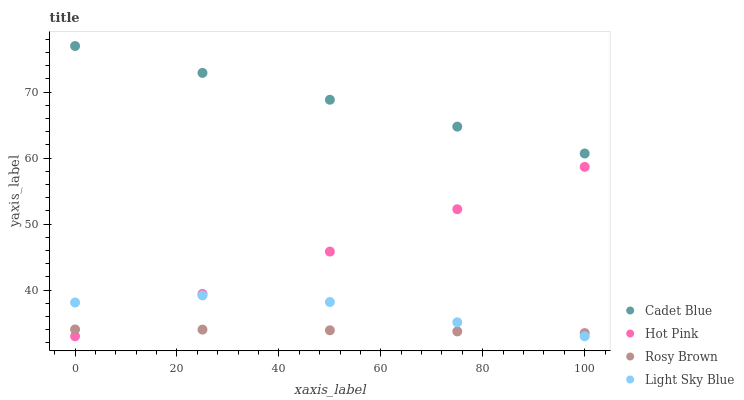Does Rosy Brown have the minimum area under the curve?
Answer yes or no. Yes. Does Cadet Blue have the maximum area under the curve?
Answer yes or no. Yes. Does Light Sky Blue have the minimum area under the curve?
Answer yes or no. No. Does Light Sky Blue have the maximum area under the curve?
Answer yes or no. No. Is Hot Pink the smoothest?
Answer yes or no. Yes. Is Light Sky Blue the roughest?
Answer yes or no. Yes. Is Cadet Blue the smoothest?
Answer yes or no. No. Is Cadet Blue the roughest?
Answer yes or no. No. Does Light Sky Blue have the lowest value?
Answer yes or no. Yes. Does Cadet Blue have the lowest value?
Answer yes or no. No. Does Cadet Blue have the highest value?
Answer yes or no. Yes. Does Light Sky Blue have the highest value?
Answer yes or no. No. Is Light Sky Blue less than Cadet Blue?
Answer yes or no. Yes. Is Cadet Blue greater than Rosy Brown?
Answer yes or no. Yes. Does Hot Pink intersect Light Sky Blue?
Answer yes or no. Yes. Is Hot Pink less than Light Sky Blue?
Answer yes or no. No. Is Hot Pink greater than Light Sky Blue?
Answer yes or no. No. Does Light Sky Blue intersect Cadet Blue?
Answer yes or no. No. 